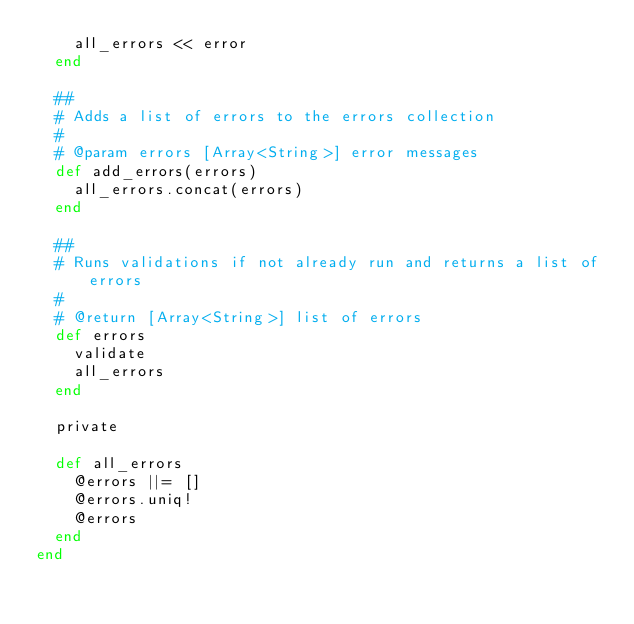<code> <loc_0><loc_0><loc_500><loc_500><_Ruby_>    all_errors << error
  end

  ##
  # Adds a list of errors to the errors collection
  #
  # @param errors [Array<String>] error messages
  def add_errors(errors)
    all_errors.concat(errors)
  end

  ##
  # Runs validations if not already run and returns a list of errors
  #
  # @return [Array<String>] list of errors
  def errors
    validate
    all_errors
  end

  private

  def all_errors
    @errors ||= []
    @errors.uniq!
    @errors
  end
end
</code> 